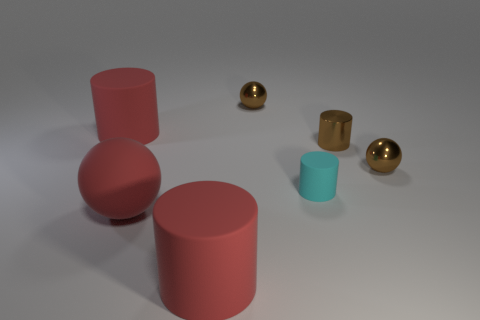Add 3 small matte cylinders. How many objects exist? 10 Subtract all cylinders. How many objects are left? 3 Subtract 1 red cylinders. How many objects are left? 6 Subtract all cyan rubber cylinders. Subtract all large cylinders. How many objects are left? 4 Add 3 tiny cyan things. How many tiny cyan things are left? 4 Add 6 balls. How many balls exist? 9 